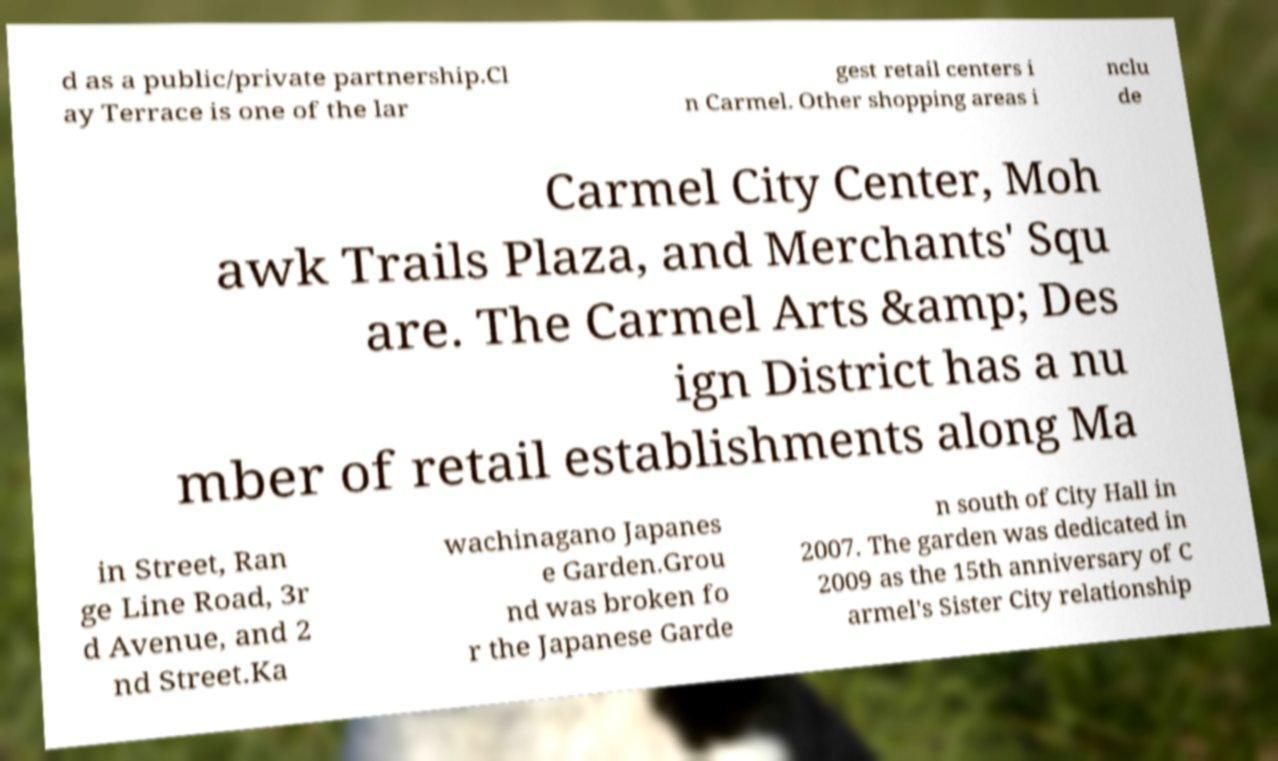I need the written content from this picture converted into text. Can you do that? d as a public/private partnership.Cl ay Terrace is one of the lar gest retail centers i n Carmel. Other shopping areas i nclu de Carmel City Center, Moh awk Trails Plaza, and Merchants' Squ are. The Carmel Arts &amp; Des ign District has a nu mber of retail establishments along Ma in Street, Ran ge Line Road, 3r d Avenue, and 2 nd Street.Ka wachinagano Japanes e Garden.Grou nd was broken fo r the Japanese Garde n south of City Hall in 2007. The garden was dedicated in 2009 as the 15th anniversary of C armel's Sister City relationship 